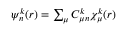Convert formula to latex. <formula><loc_0><loc_0><loc_500><loc_500>\begin{array} { r } { \psi _ { n } ^ { k } ( r ) = \sum _ { \mu } C _ { \mu n } ^ { k } \chi _ { \mu } ^ { k } ( r ) } \end{array}</formula> 